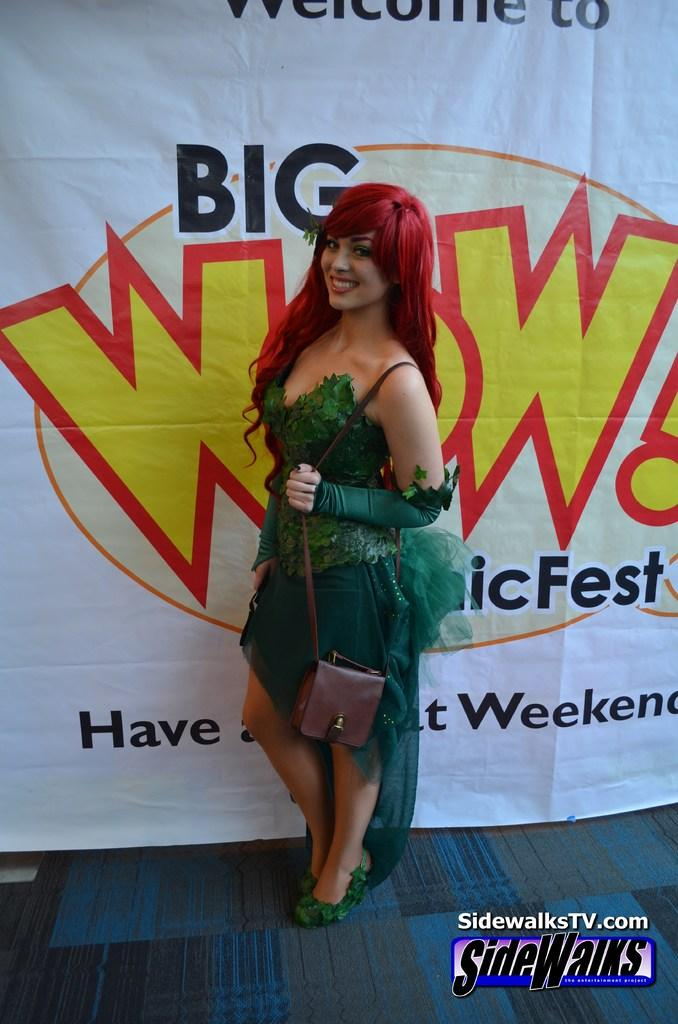Who is the main subject in the image? There is a lady in the image. What is the lady wearing? The lady is wearing a green dress. What is the lady holding in the image? The lady is holding a bag. What is the lady's facial expression in the image? The lady is standing and smiling. What can be seen behind the lady in the image? There is a banner behind the lady. How many bikes are parked next to the lady in the image? There are no bikes present in the image. 